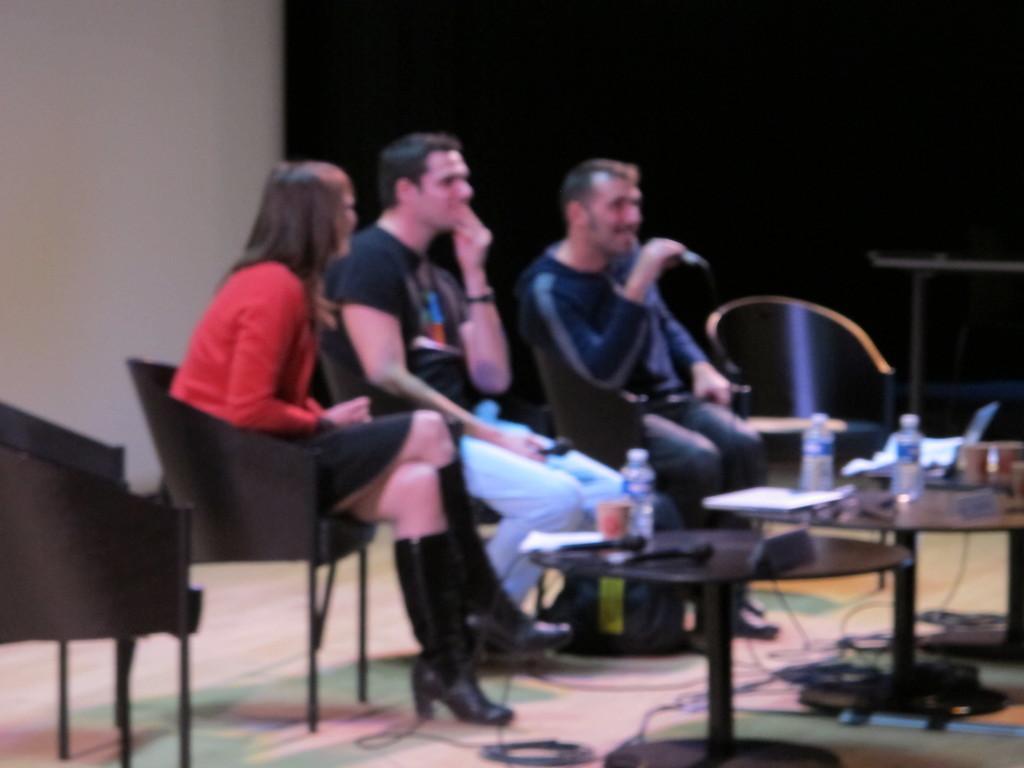In one or two sentences, can you explain what this image depicts? In this image I see 2 men and a women sitting on the chairs, I also see a chair on the either side. In front there is a table and lot of things on it. 